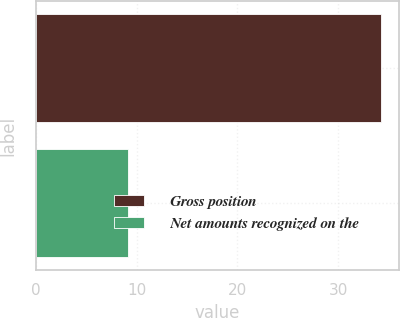Convert chart to OTSL. <chart><loc_0><loc_0><loc_500><loc_500><bar_chart><fcel>Gross position<fcel>Net amounts recognized on the<nl><fcel>34.3<fcel>9.1<nl></chart> 